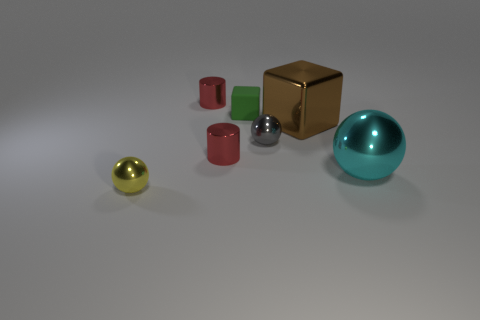Are there any other things that are made of the same material as the small block?
Your answer should be compact. No. What number of other things are there of the same shape as the tiny green object?
Keep it short and to the point. 1. What number of objects are either metallic cylinders that are in front of the gray metallic ball or objects that are on the left side of the brown shiny cube?
Offer a very short reply. 5. There is a shiny ball that is behind the yellow metallic object and left of the large brown thing; what is its size?
Give a very brief answer. Small. Do the big metal object that is on the left side of the cyan metallic object and the green thing have the same shape?
Provide a short and direct response. Yes. There is a gray sphere behind the red cylinder that is in front of the small shiny sphere on the right side of the small yellow shiny object; what is its size?
Offer a very short reply. Small. What number of things are matte spheres or large brown blocks?
Your answer should be very brief. 1. There is a object that is both on the right side of the tiny gray ball and in front of the big block; what shape is it?
Keep it short and to the point. Sphere. There is a tiny green object; is its shape the same as the large brown metallic object in front of the tiny block?
Your response must be concise. Yes. Are there any small gray metallic objects in front of the small block?
Offer a terse response. Yes. 